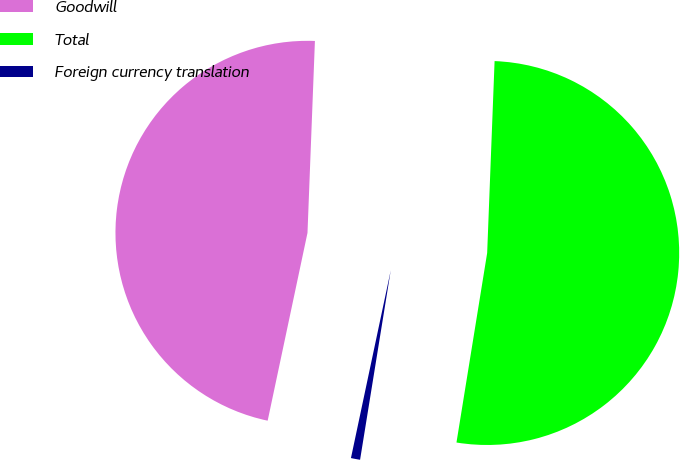Convert chart to OTSL. <chart><loc_0><loc_0><loc_500><loc_500><pie_chart><fcel>Goodwill<fcel>Total<fcel>Foreign currency translation<nl><fcel>47.29%<fcel>51.94%<fcel>0.77%<nl></chart> 